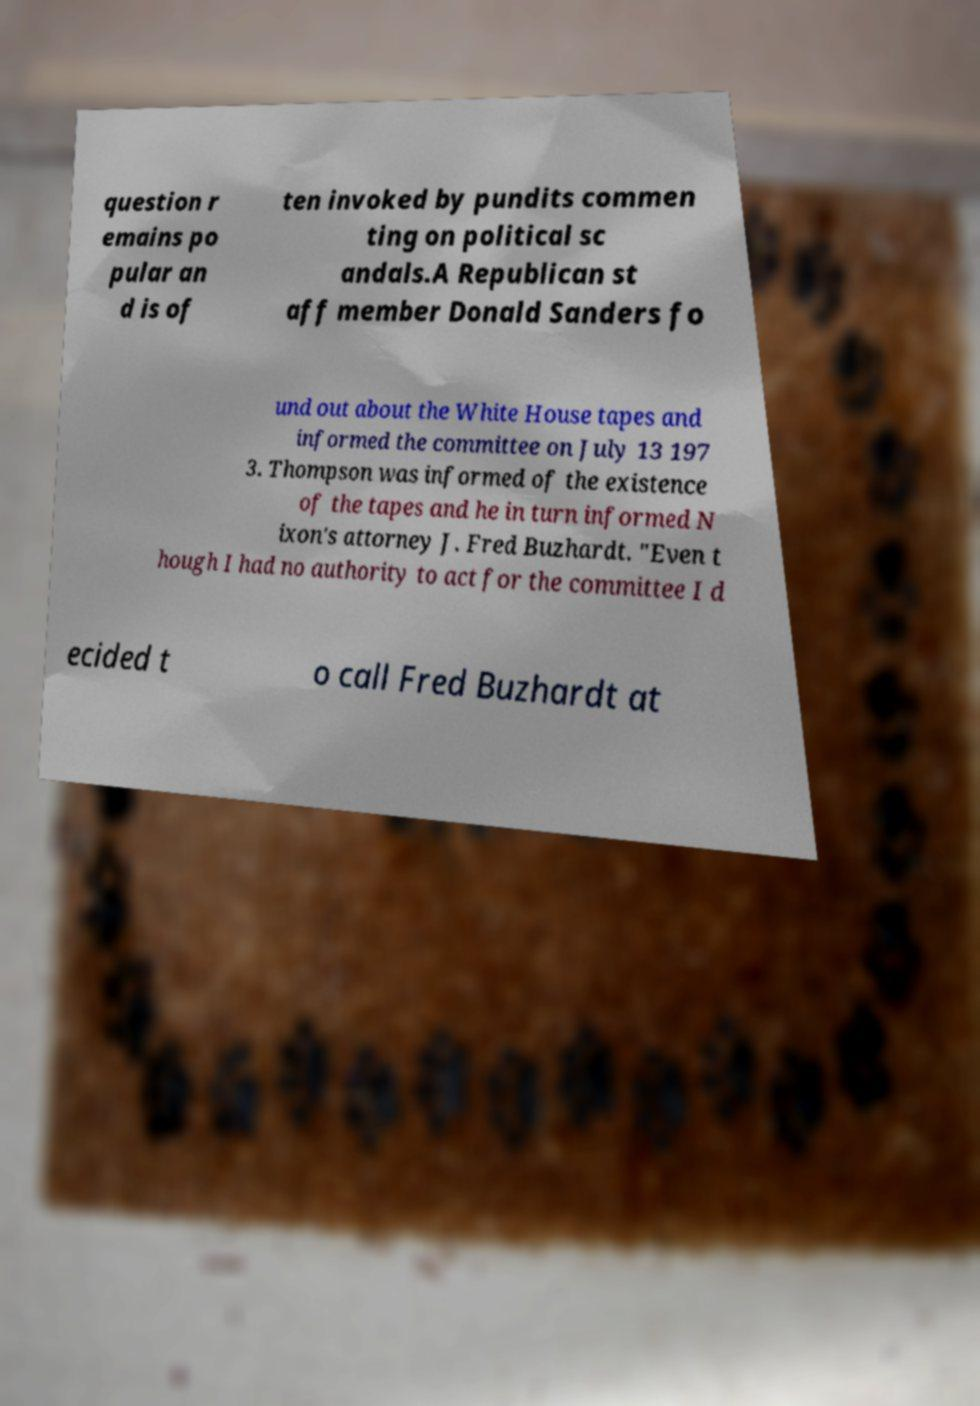Please read and relay the text visible in this image. What does it say? question r emains po pular an d is of ten invoked by pundits commen ting on political sc andals.A Republican st aff member Donald Sanders fo und out about the White House tapes and informed the committee on July 13 197 3. Thompson was informed of the existence of the tapes and he in turn informed N ixon's attorney J. Fred Buzhardt. "Even t hough I had no authority to act for the committee I d ecided t o call Fred Buzhardt at 